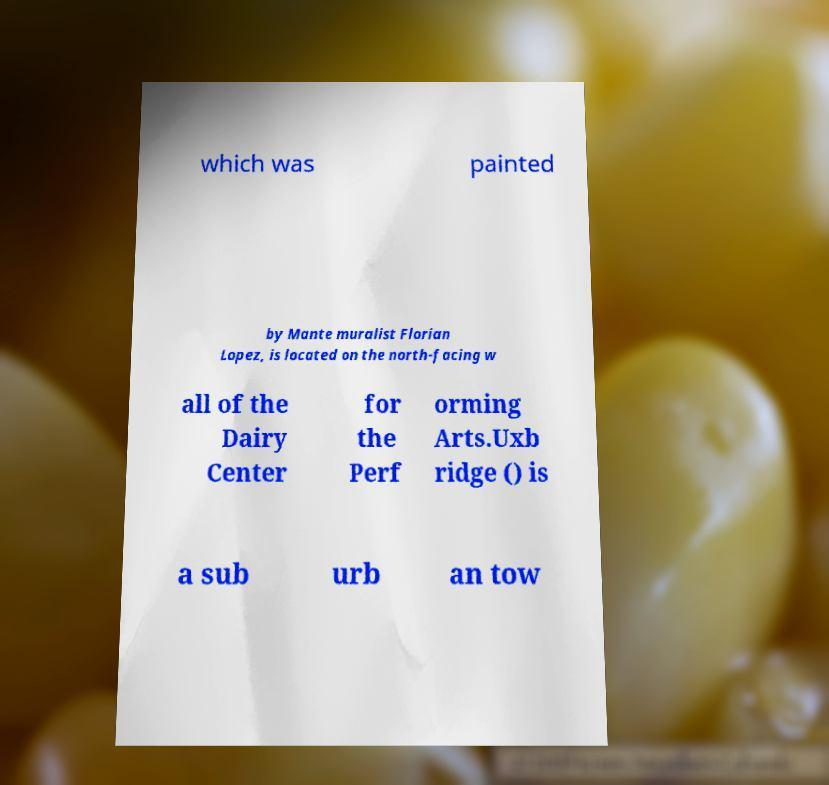Please read and relay the text visible in this image. What does it say? which was painted by Mante muralist Florian Lopez, is located on the north-facing w all of the Dairy Center for the Perf orming Arts.Uxb ridge () is a sub urb an tow 